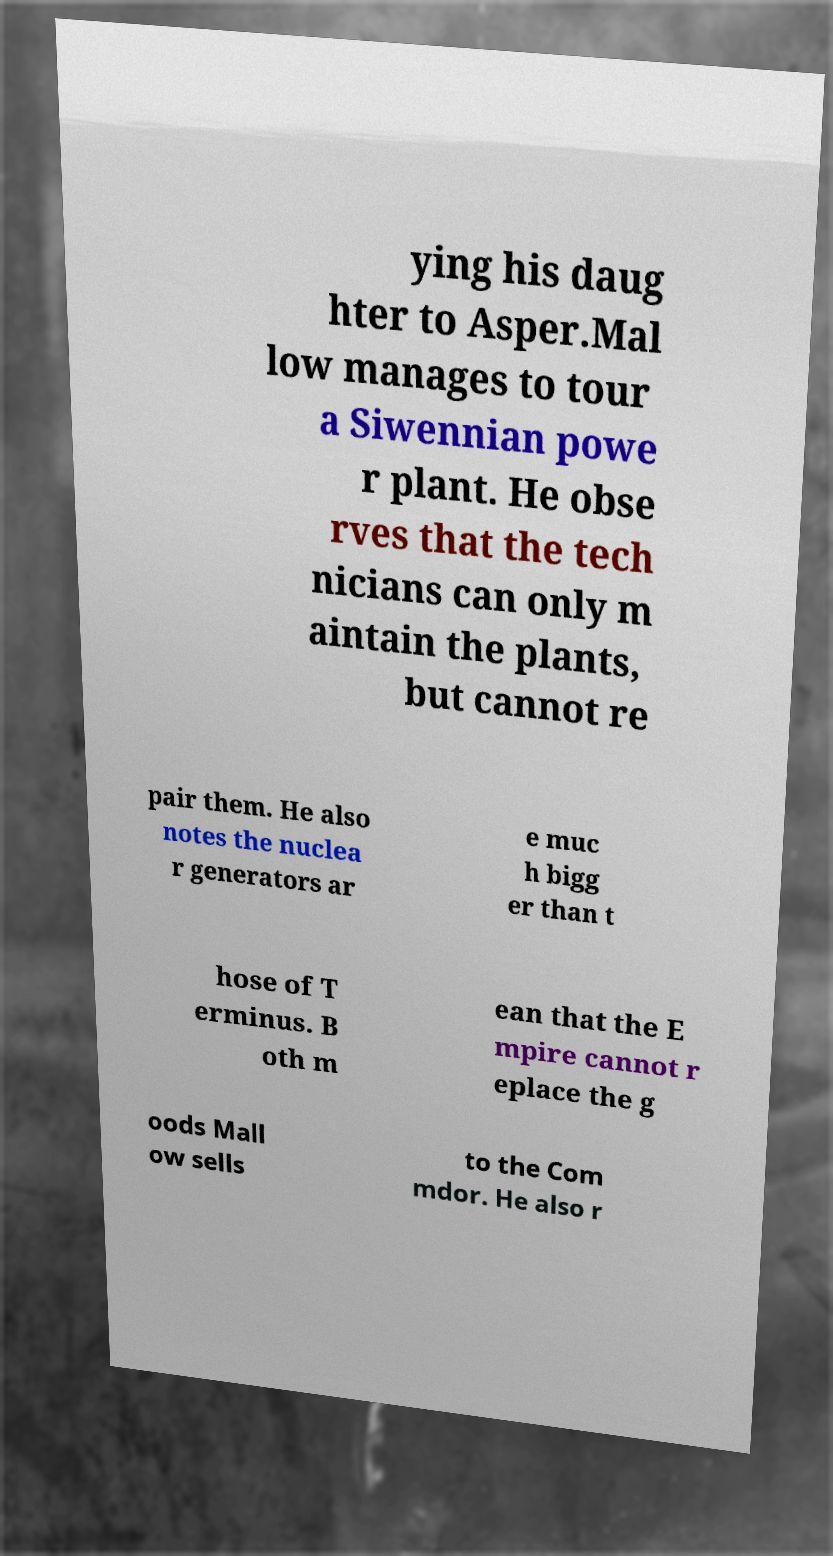Can you accurately transcribe the text from the provided image for me? ying his daug hter to Asper.Mal low manages to tour a Siwennian powe r plant. He obse rves that the tech nicians can only m aintain the plants, but cannot re pair them. He also notes the nuclea r generators ar e muc h bigg er than t hose of T erminus. B oth m ean that the E mpire cannot r eplace the g oods Mall ow sells to the Com mdor. He also r 